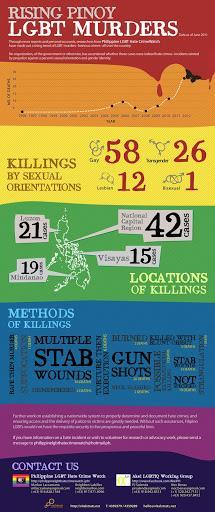Which is the most used method of killing?
Answer the question with a short phrase. Stab 